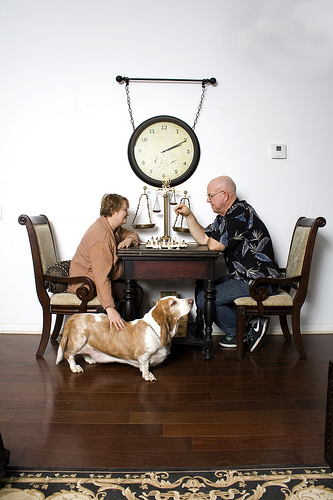<image>
Is there a human above the dog? Yes. The human is positioned above the dog in the vertical space, higher up in the scene. 